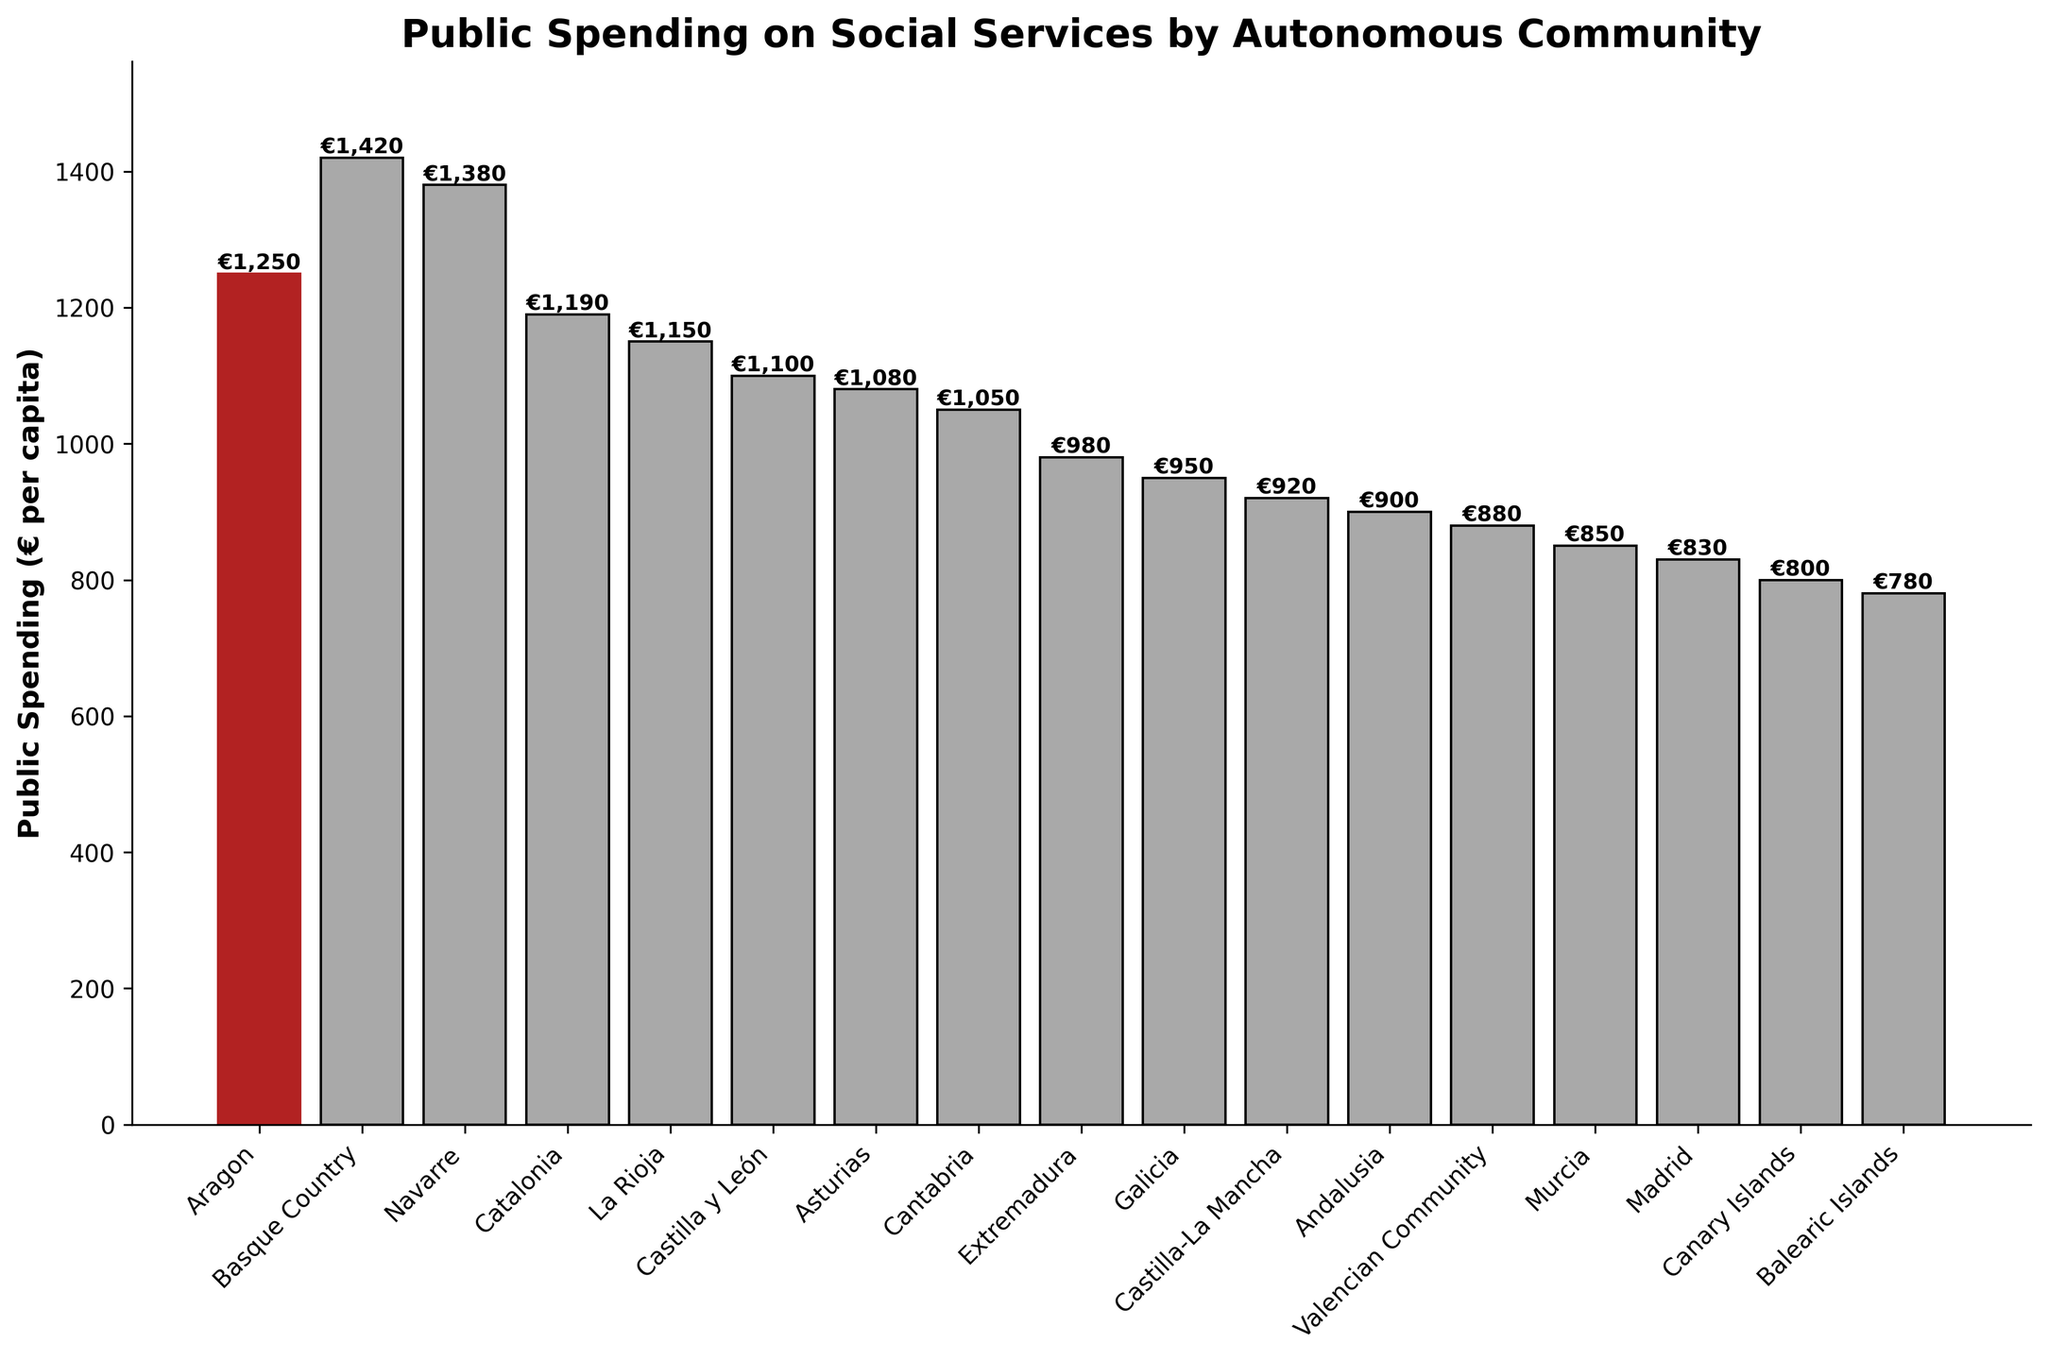What's the public spending on social services in Aragon? By looking at the bar chart, we can see that the bar representing Aragon is highlighted in firebrick color. The height of this bar is labeled with the value €1250.
Answer: €1250 Which community has the highest public spending on social services? Among all the bars in the chart, the bar for Basque Country is the tallest, indicating the highest public spending, which is €1420.
Answer: Basque Country What is the difference in public spending between Aragon and Catalonia? The chart shows that Aragon has a spending of €1250 and Catalonia has €1190. The difference is €1250 - €1190.
Answer: €60 Is Aragon's public spending higher or lower than the average public spending shown on the chart? To determine this, we need to calculate the average spending of all communities and compare it to Aragon's spending (€1250). The average is (1250 + 1420 + 1380 + 1190 + 1150 + 1100 + 1080 + 1050 + 980 + 950 + 920 + 900 + 880 + 850 + 830 + 800 + 780) / 17 = €1030. Aragon's spending (€1250) is higher than the average (€1030).
Answer: Higher Which community has the lowest public spending on social services and what is the amount? According to the chart, Balearic Islands have the lowest bar and are labeled with €780.
Answer: Balearic Islands, €780 By how much does Aragon's public spending exceed the spending in Madrid? The chart shows that Aragon's spending is €1250, and Madrid's is €830. The difference is €1250 - €830.
Answer: €420 What is the median value of public spending on social services across the communities? To find the median, sort the spending values: 780, 800, 830, 850, 880, 900, 920, 950, 980, 1050, 1080, 1100, 1150, 1190, 1250, 1380, 1420. The median is the middle value (9th value out of 17): €980.
Answer: €980 How many communities have a lower spending than Aragon? From the chart, count the bars with a height lower than Aragon's bar (€1250). These are: La Rioja, Castilla y León, Asturias, Cantabria, Extremadura, Galicia, Castilla-La Mancha, Andalusia, Valencian Community, Murcia, Madrid, Canary Islands, Balearic Islands - 13 communities.
Answer: 13 If Aragon's public spending were to be increased by 10%, what would be the new amount? Calculate a 10% increase on €1250: 1250 * 0.10 = 125. Add this to the original amount: 1250 + 125.
Answer: €1375 